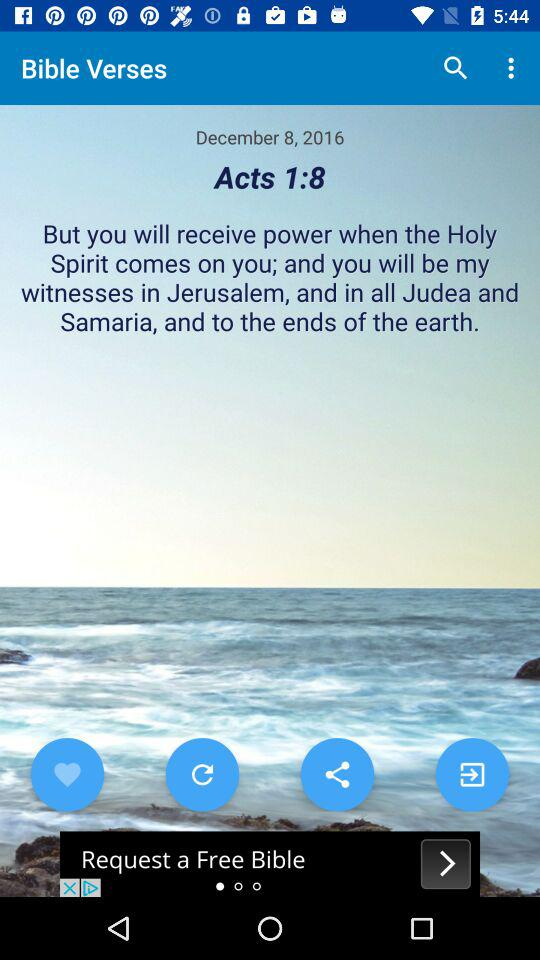What is the mentioned date in "Bible Verses"? The mentioned date in "Bible Verses" is December 8, 2016. 